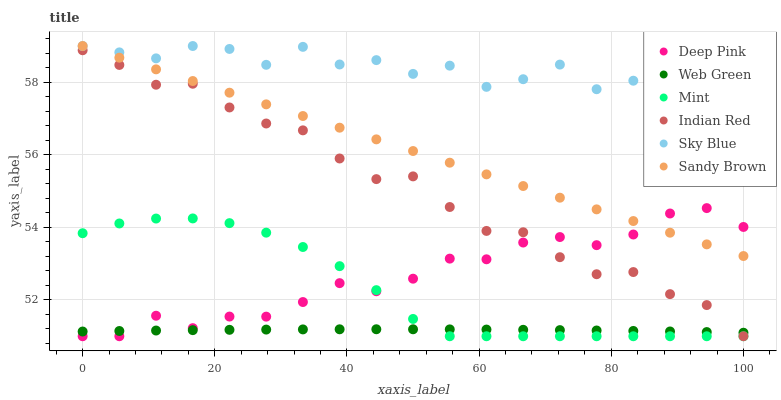Does Web Green have the minimum area under the curve?
Answer yes or no. Yes. Does Sky Blue have the maximum area under the curve?
Answer yes or no. Yes. Does Mint have the minimum area under the curve?
Answer yes or no. No. Does Mint have the maximum area under the curve?
Answer yes or no. No. Is Sandy Brown the smoothest?
Answer yes or no. Yes. Is Sky Blue the roughest?
Answer yes or no. Yes. Is Mint the smoothest?
Answer yes or no. No. Is Mint the roughest?
Answer yes or no. No. Does Deep Pink have the lowest value?
Answer yes or no. Yes. Does Web Green have the lowest value?
Answer yes or no. No. Does Sandy Brown have the highest value?
Answer yes or no. Yes. Does Mint have the highest value?
Answer yes or no. No. Is Indian Red less than Sandy Brown?
Answer yes or no. Yes. Is Sandy Brown greater than Mint?
Answer yes or no. Yes. Does Web Green intersect Indian Red?
Answer yes or no. Yes. Is Web Green less than Indian Red?
Answer yes or no. No. Is Web Green greater than Indian Red?
Answer yes or no. No. Does Indian Red intersect Sandy Brown?
Answer yes or no. No. 